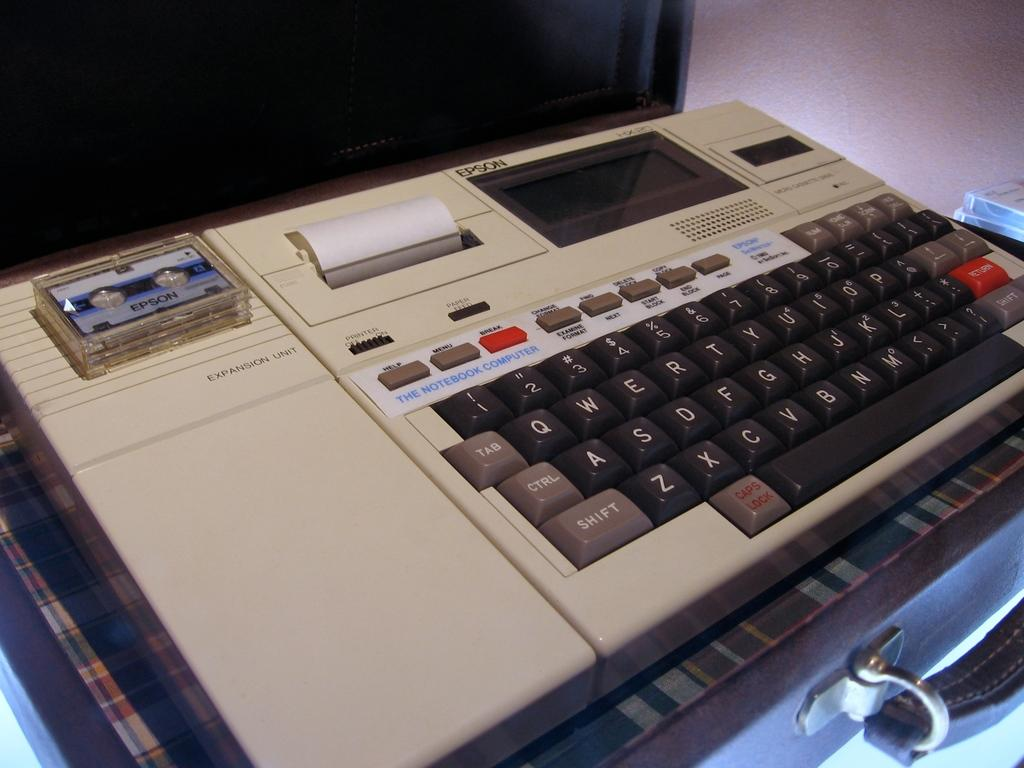<image>
Give a short and clear explanation of the subsequent image. a device with an Epson tape in it 